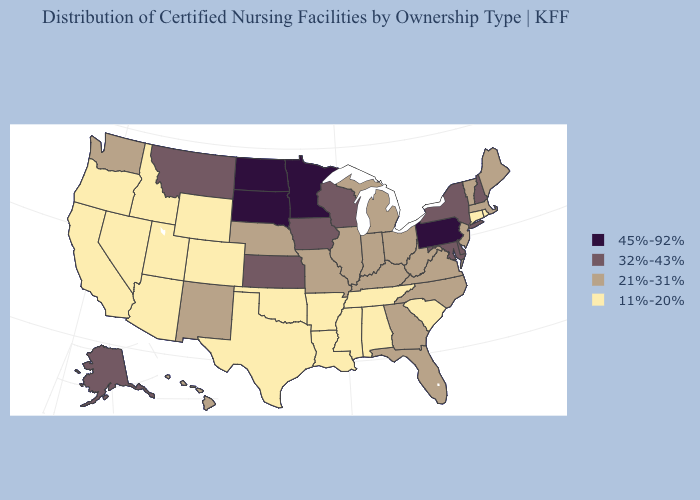Does Maryland have a higher value than South Dakota?
Quick response, please. No. Does Maryland have the highest value in the USA?
Be succinct. No. Does the first symbol in the legend represent the smallest category?
Give a very brief answer. No. Does Vermont have a lower value than Illinois?
Keep it brief. No. Name the states that have a value in the range 11%-20%?
Write a very short answer. Alabama, Arizona, Arkansas, California, Colorado, Connecticut, Idaho, Louisiana, Mississippi, Nevada, Oklahoma, Oregon, Rhode Island, South Carolina, Tennessee, Texas, Utah, Wyoming. Which states have the lowest value in the West?
Write a very short answer. Arizona, California, Colorado, Idaho, Nevada, Oregon, Utah, Wyoming. Does New Mexico have the same value as Wyoming?
Write a very short answer. No. What is the value of Missouri?
Answer briefly. 21%-31%. What is the value of California?
Answer briefly. 11%-20%. Does the map have missing data?
Short answer required. No. Does Colorado have the lowest value in the West?
Write a very short answer. Yes. Does Rhode Island have the highest value in the USA?
Give a very brief answer. No. What is the value of Tennessee?
Concise answer only. 11%-20%. What is the value of Wyoming?
Quick response, please. 11%-20%. Does New Jersey have the lowest value in the Northeast?
Answer briefly. No. 